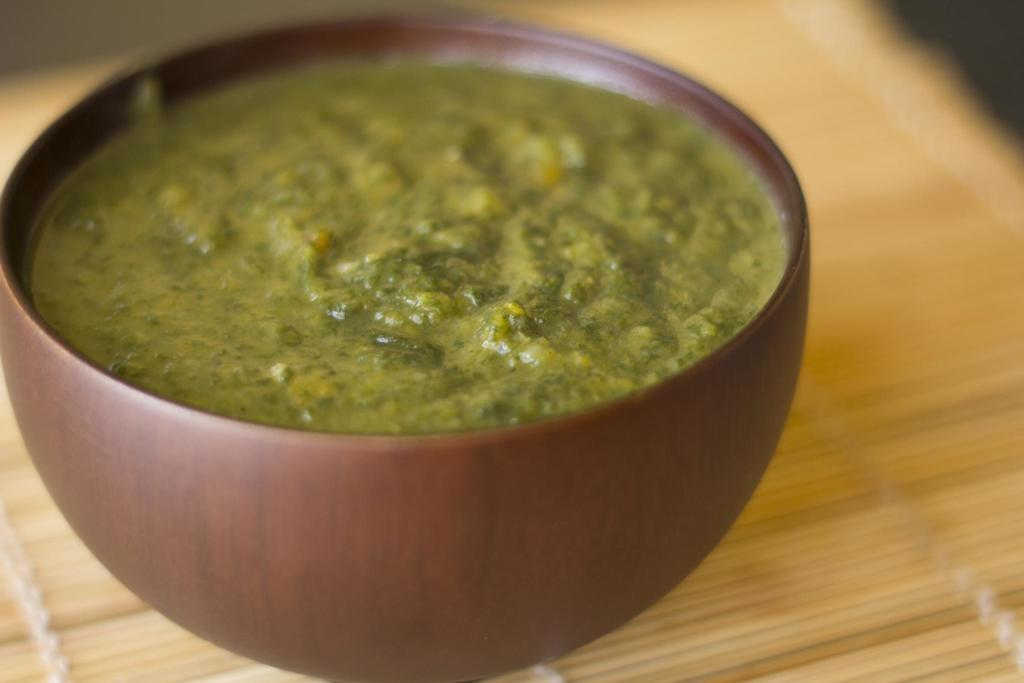What color is the bowl in the image? The bowl in the image is brown colored. What is the bowl placed on? The bowl is placed on a cream colored wooden surface. What type of food item is in the bowl? There is a green food item in the bowl. What type of cemetery can be seen in the background of the image? There is no cemetery present in the image; it only features a brown colored bowl on a cream colored wooden surface with a green food item inside. 